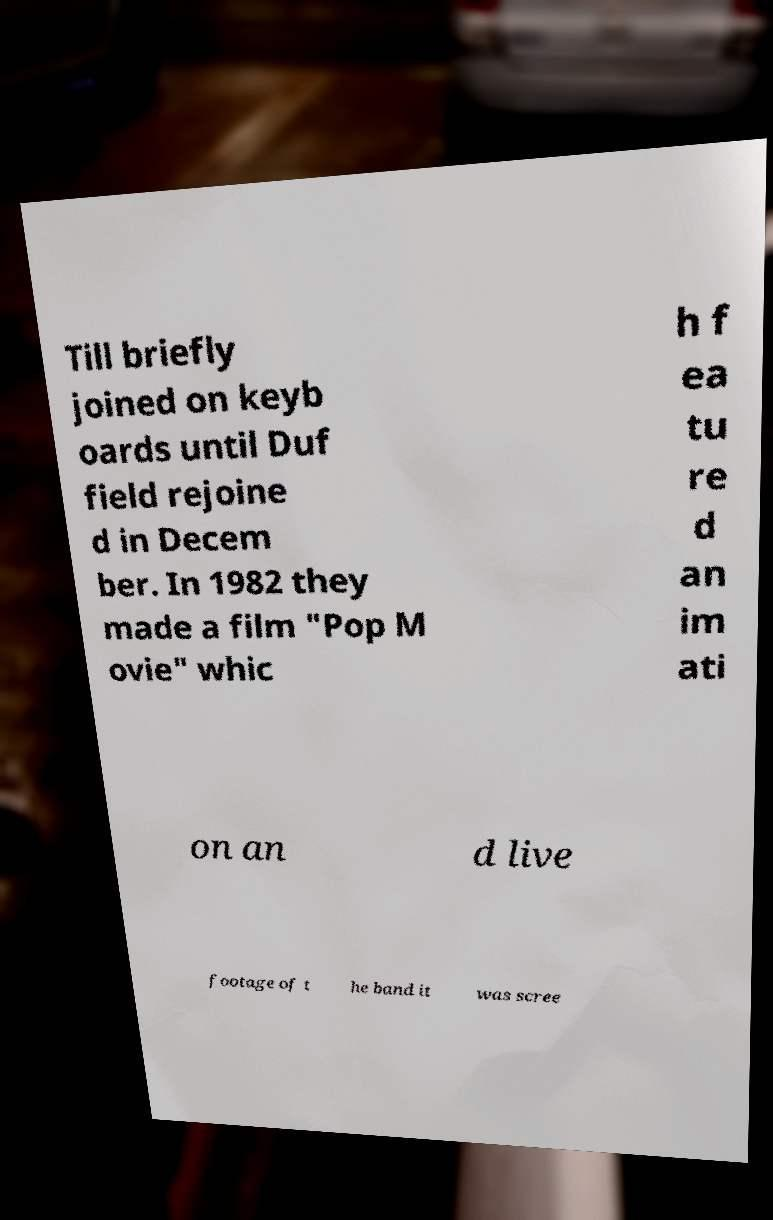Please identify and transcribe the text found in this image. Till briefly joined on keyb oards until Duf field rejoine d in Decem ber. In 1982 they made a film "Pop M ovie" whic h f ea tu re d an im ati on an d live footage of t he band it was scree 